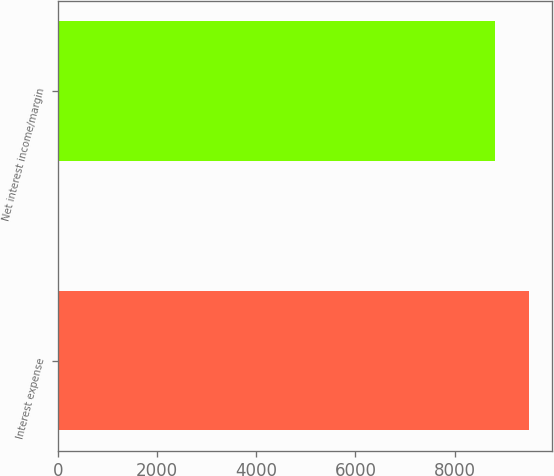Convert chart. <chart><loc_0><loc_0><loc_500><loc_500><bar_chart><fcel>Interest expense<fcel>Net interest income/margin<nl><fcel>9495<fcel>8822<nl></chart> 